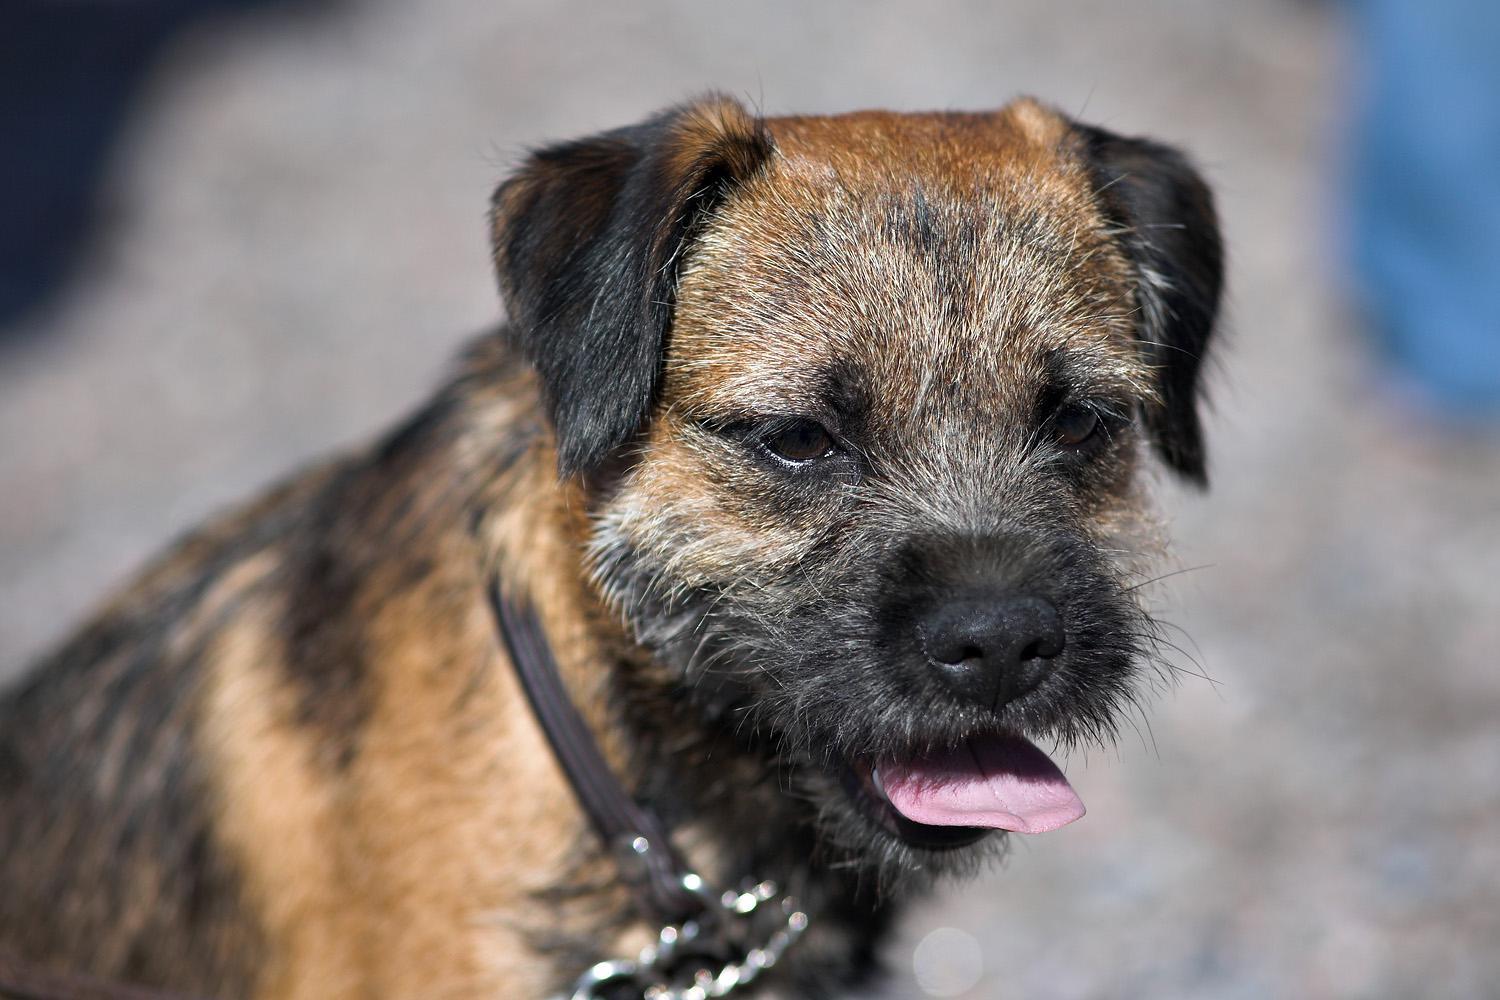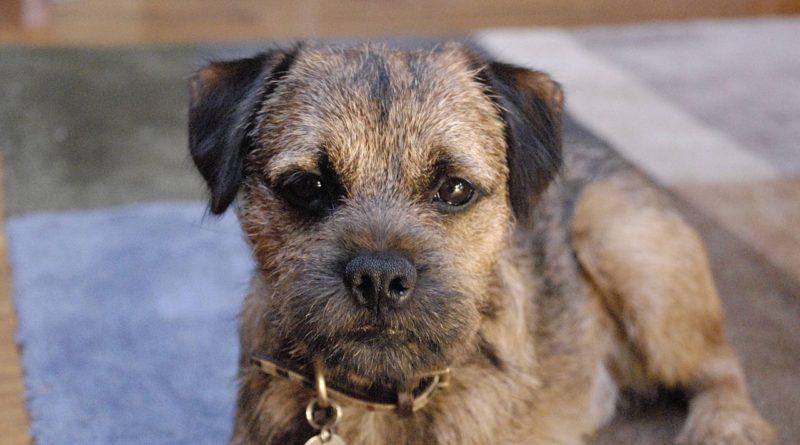The first image is the image on the left, the second image is the image on the right. For the images shown, is this caption "The left and right image contains the same number of dogs with at least one in the grass." true? Answer yes or no. No. The first image is the image on the left, the second image is the image on the right. Analyze the images presented: Is the assertion "One image includes a dog that is sitting upright, and the other image contains a single dog which is standing up." valid? Answer yes or no. No. 